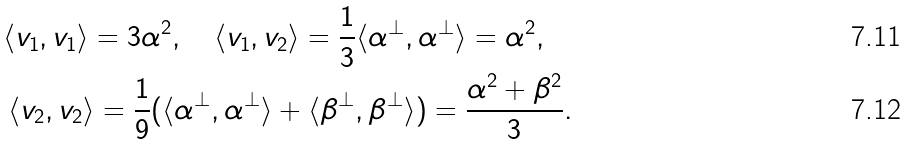<formula> <loc_0><loc_0><loc_500><loc_500>\langle v _ { 1 } , v _ { 1 } \rangle = 3 \alpha ^ { 2 } , \quad \langle v _ { 1 } , v _ { 2 } \rangle = \frac { 1 } { 3 } \langle \alpha ^ { \perp } , \alpha ^ { \perp } \rangle = \alpha ^ { 2 } , \quad \\ \langle v _ { 2 } , v _ { 2 } \rangle = \frac { 1 } { 9 } ( \langle \alpha ^ { \perp } , \alpha ^ { \perp } \rangle + \langle \beta ^ { \perp } , \beta ^ { \perp } \rangle ) = \frac { \alpha ^ { 2 } + \beta ^ { 2 } } { 3 } .</formula> 